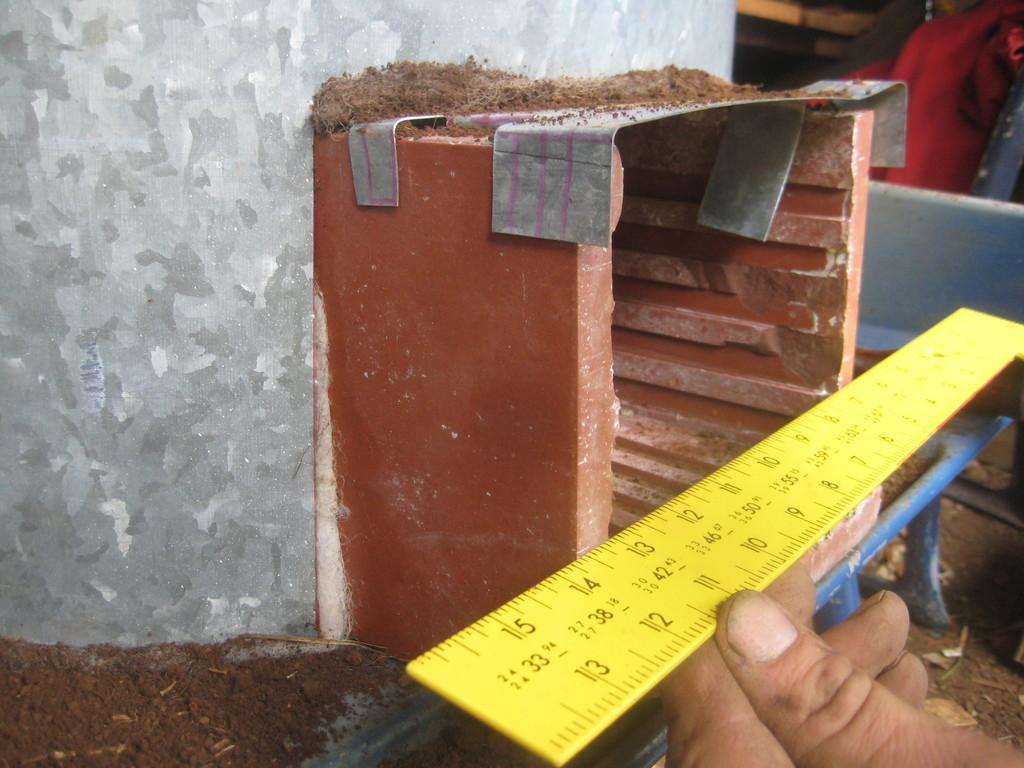<image>
Present a compact description of the photo's key features. a yellow ruler with numbers 13 and 12 on it held in front of a building project 